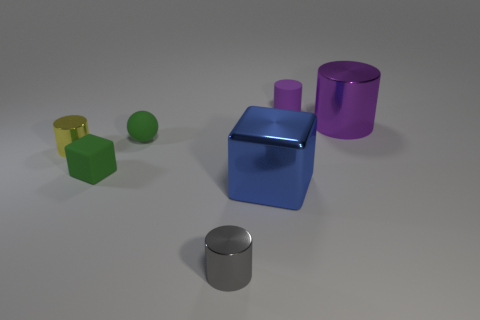Subtract all tiny cylinders. How many cylinders are left? 1 Subtract all blue blocks. How many purple cylinders are left? 2 Add 1 gray metallic cylinders. How many objects exist? 8 Subtract all yellow cylinders. How many cylinders are left? 3 Subtract all spheres. How many objects are left? 6 Add 3 small green blocks. How many small green blocks are left? 4 Add 6 large cubes. How many large cubes exist? 7 Subtract 0 blue spheres. How many objects are left? 7 Subtract all green cylinders. Subtract all cyan cubes. How many cylinders are left? 4 Subtract all small things. Subtract all tiny purple spheres. How many objects are left? 2 